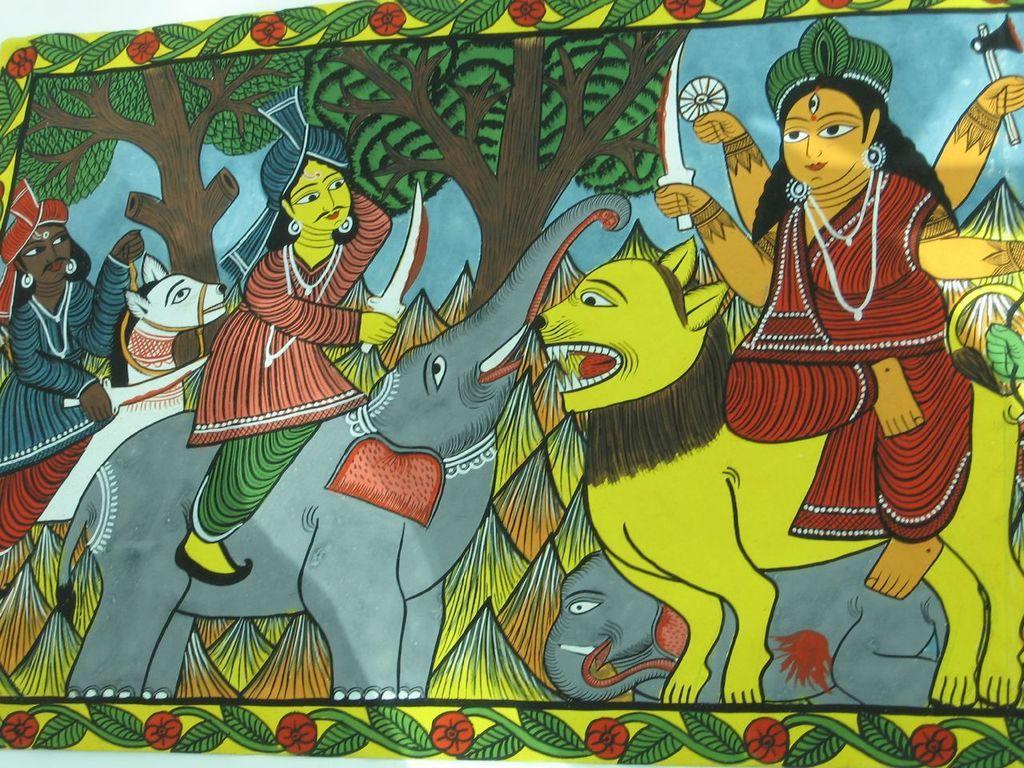Please provide a concise description of this image. In this image we can see a poster. In the poster we can see a painting of persons and animals. We can see persons are holding objects. Behind the persons we can the trees. There are flowers and leaves at the top and bottom of the image. 